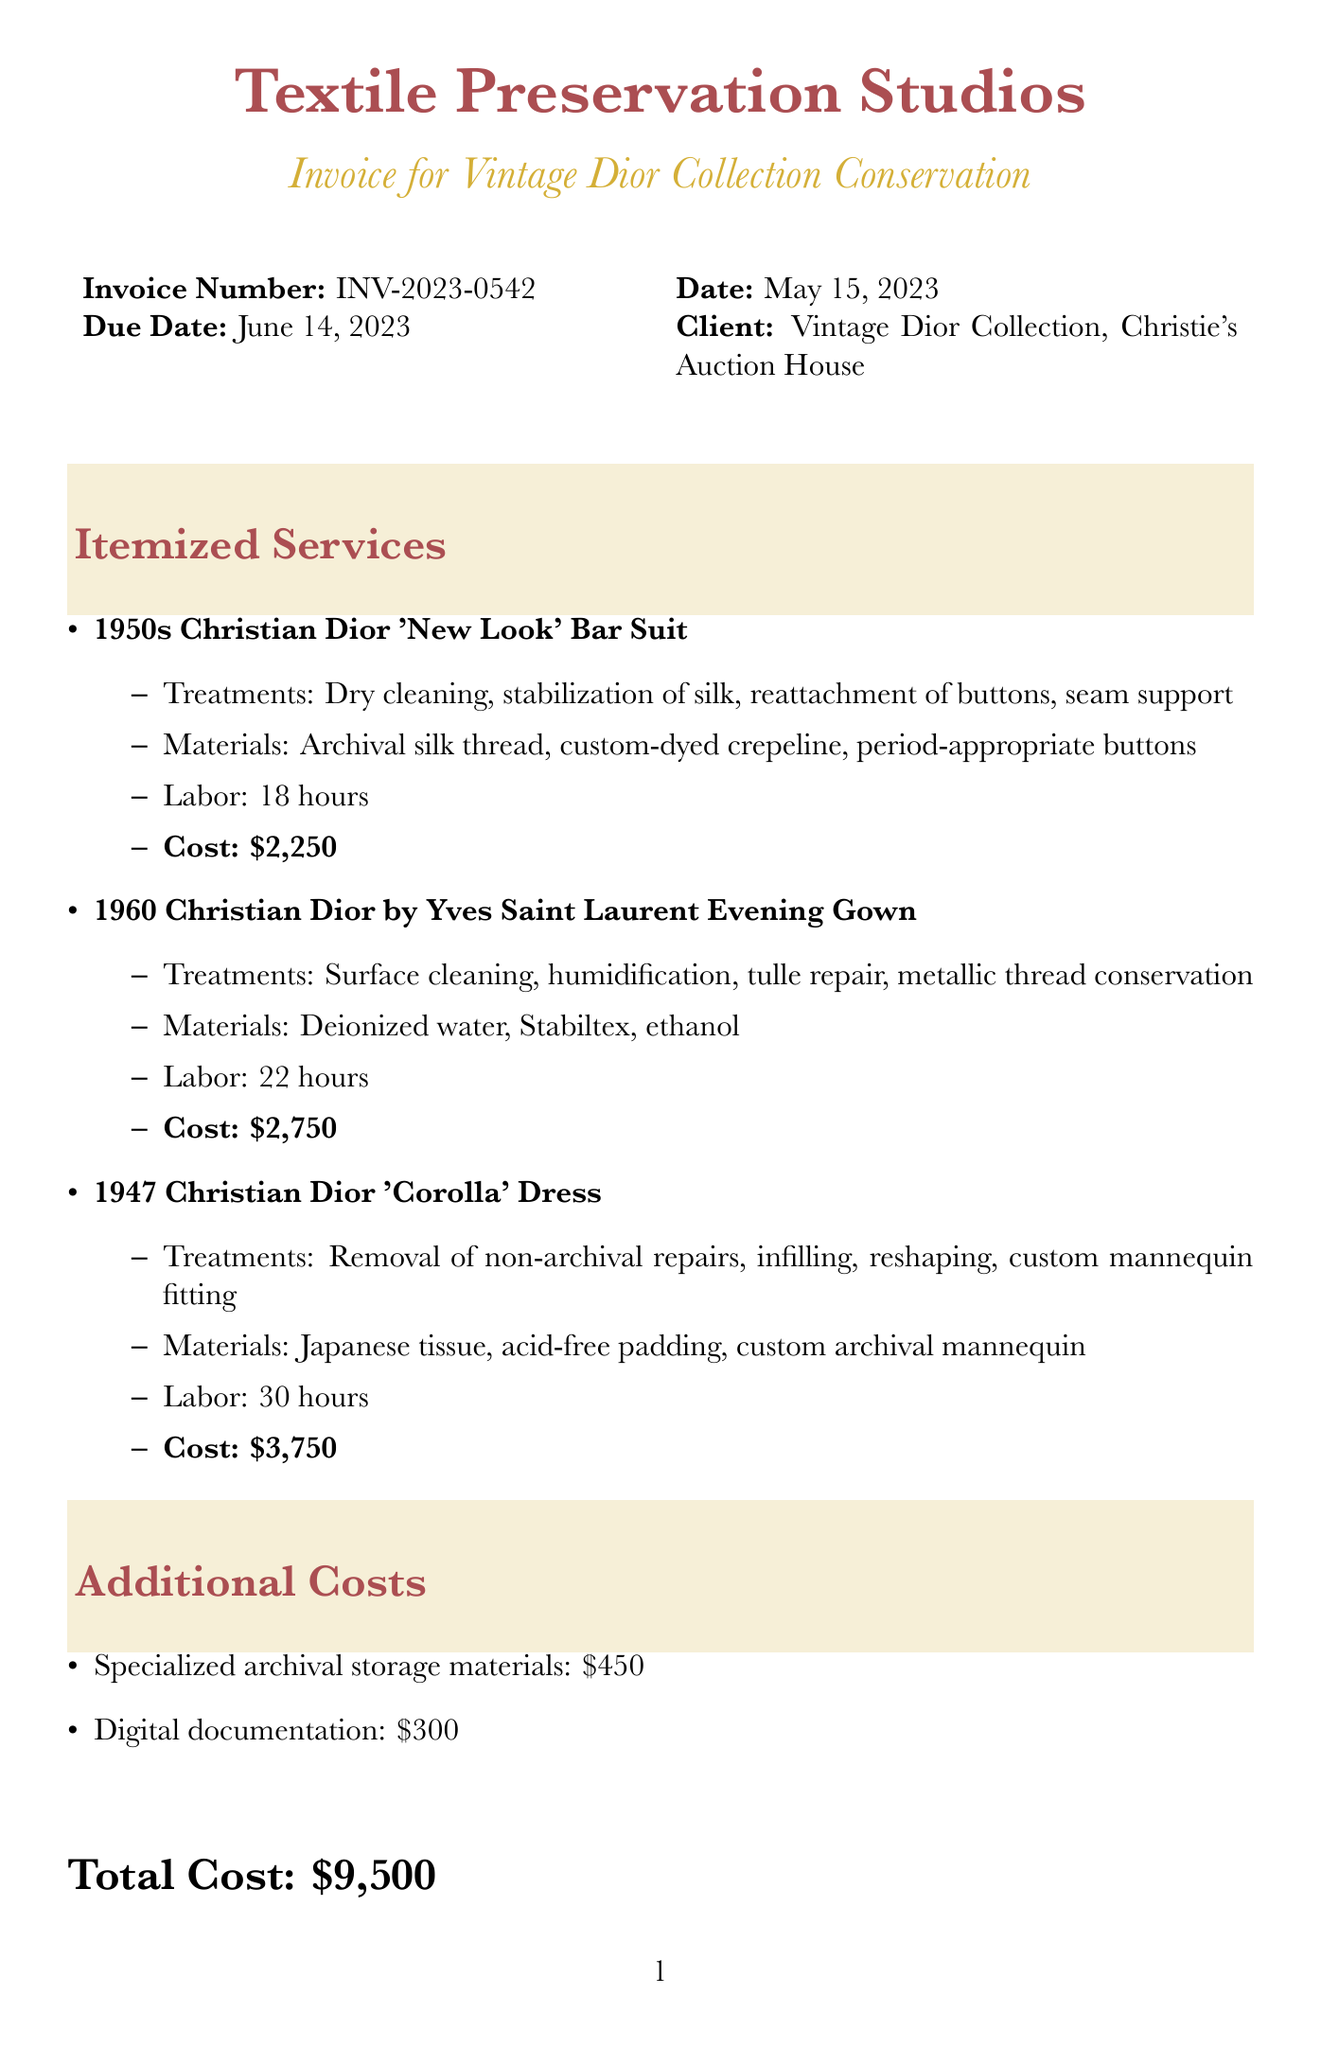What is the invoice number? The invoice number is a unique identifier found in the document, which is INV-2023-0542.
Answer: INV-2023-0542 What is the date of the invoice? The date of the invoice indicates when the document was issued, which is May 15, 2023.
Answer: May 15, 2023 Who is the conservator? The conservator is the organization providing the conservation services, listed as Textile Preservation Studios.
Answer: Textile Preservation Studios How many labor hours were spent on the 1950s Christian Dior 'New Look' Bar Suit? The labor hours spent on this item are noted in the document, totaling 18 hours.
Answer: 18 What is the total cost of conservation services? The total cost summarizes all expenses outlined in the invoice, which is $9,500.
Answer: $9,500 What treatment was done on the 1960 Christian Dior by Yves Saint Laurent Evening Gown? One of the treatments listed includes surface cleaning of beadwork.
Answer: Surface cleaning of beadwork What materials were used for the 1947 Christian Dior 'Corolla' Dress? One of the materials specified for this dress is Japanese tissue for infills.
Answer: Japanese tissue What additional cost is associated with digital documentation? The invoice lists the cost for digital documentation as $300.
Answer: $300 What is stated about the certificate of conservation provided for each item? The notes mention that the certificate enhances provenance for future auctions.
Answer: Enhancing provenance for future auctions 